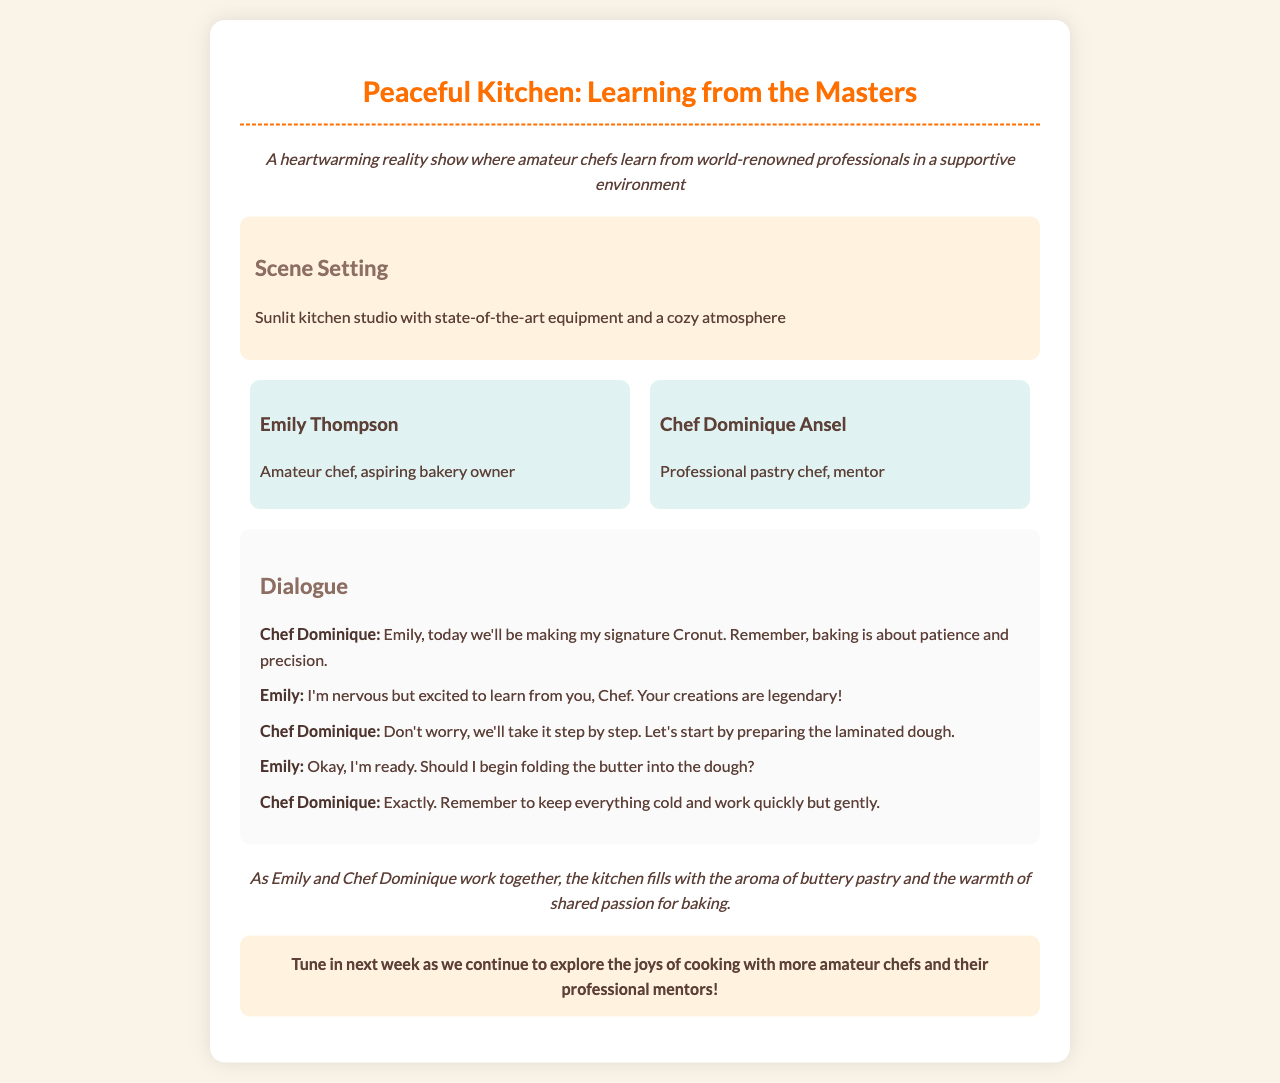What is the name of the show? The name of the show is mentioned in the title of the document.
Answer: Peaceful Kitchen: Learning from the Masters Who is the professional mentor in the show? The mentor's name is introduced in the character section of the document.
Answer: Chef Dominique Ansel What does Emily aspire to become? Emily's aspirations are stated in her character description.
Answer: Bakery owner What signature dish are they making? The dish is specified in Chef Dominique's dialogue.
Answer: Cronut What is the setting of the kitchen like? The setting description provides details about the kitchen atmosphere.
Answer: Sunlit and cozy What does Chef Dominique say is important in baking? Chef Dominique emphasizes the importance in his dialogue.
Answer: Patience and precision Which two characters are featured in this scene? The character section lists the featured characters in the show.
Answer: Emily Thompson and Chef Dominique Ansel What aroma fills the kitchen during their work? The narrator describes the sensory experience in the kitchen.
Answer: Buttery pastry What is the purpose of the next episode mentioned at the end? The closing statement gives an overview of what to expect next.
Answer: Explore the joys of cooking 